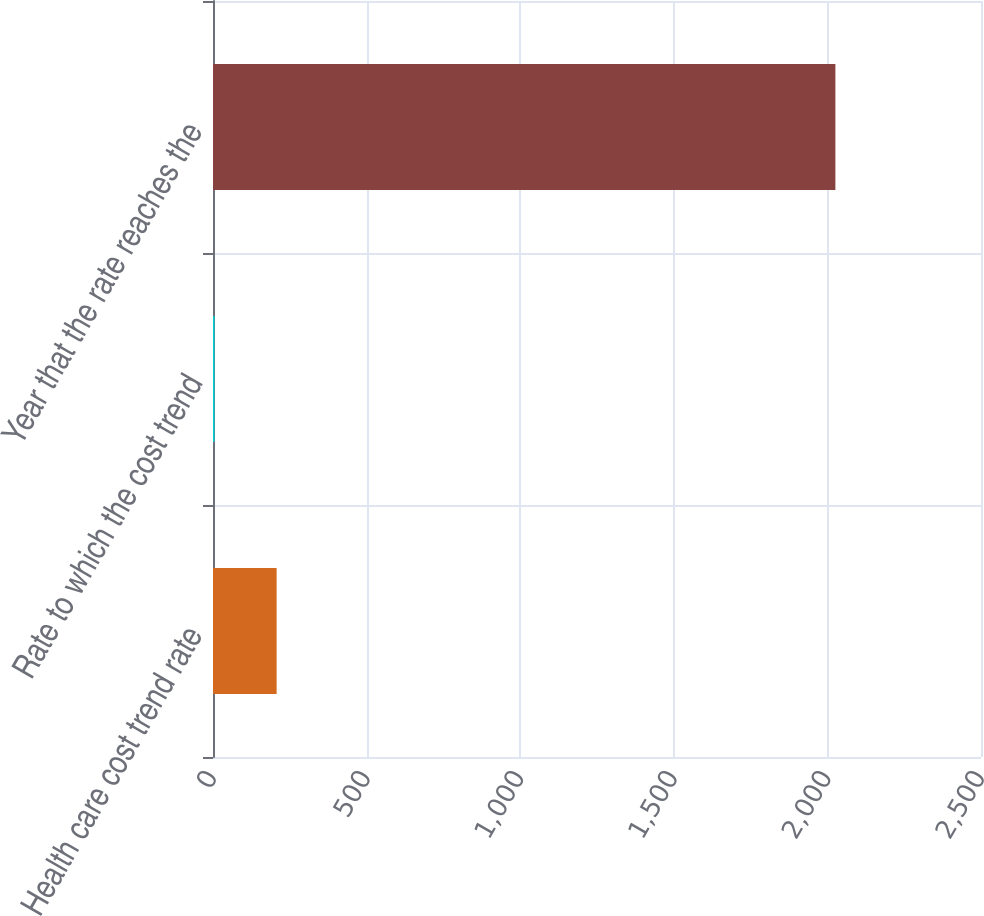<chart> <loc_0><loc_0><loc_500><loc_500><bar_chart><fcel>Health care cost trend rate<fcel>Rate to which the cost trend<fcel>Year that the rate reaches the<nl><fcel>207.1<fcel>5<fcel>2026<nl></chart> 